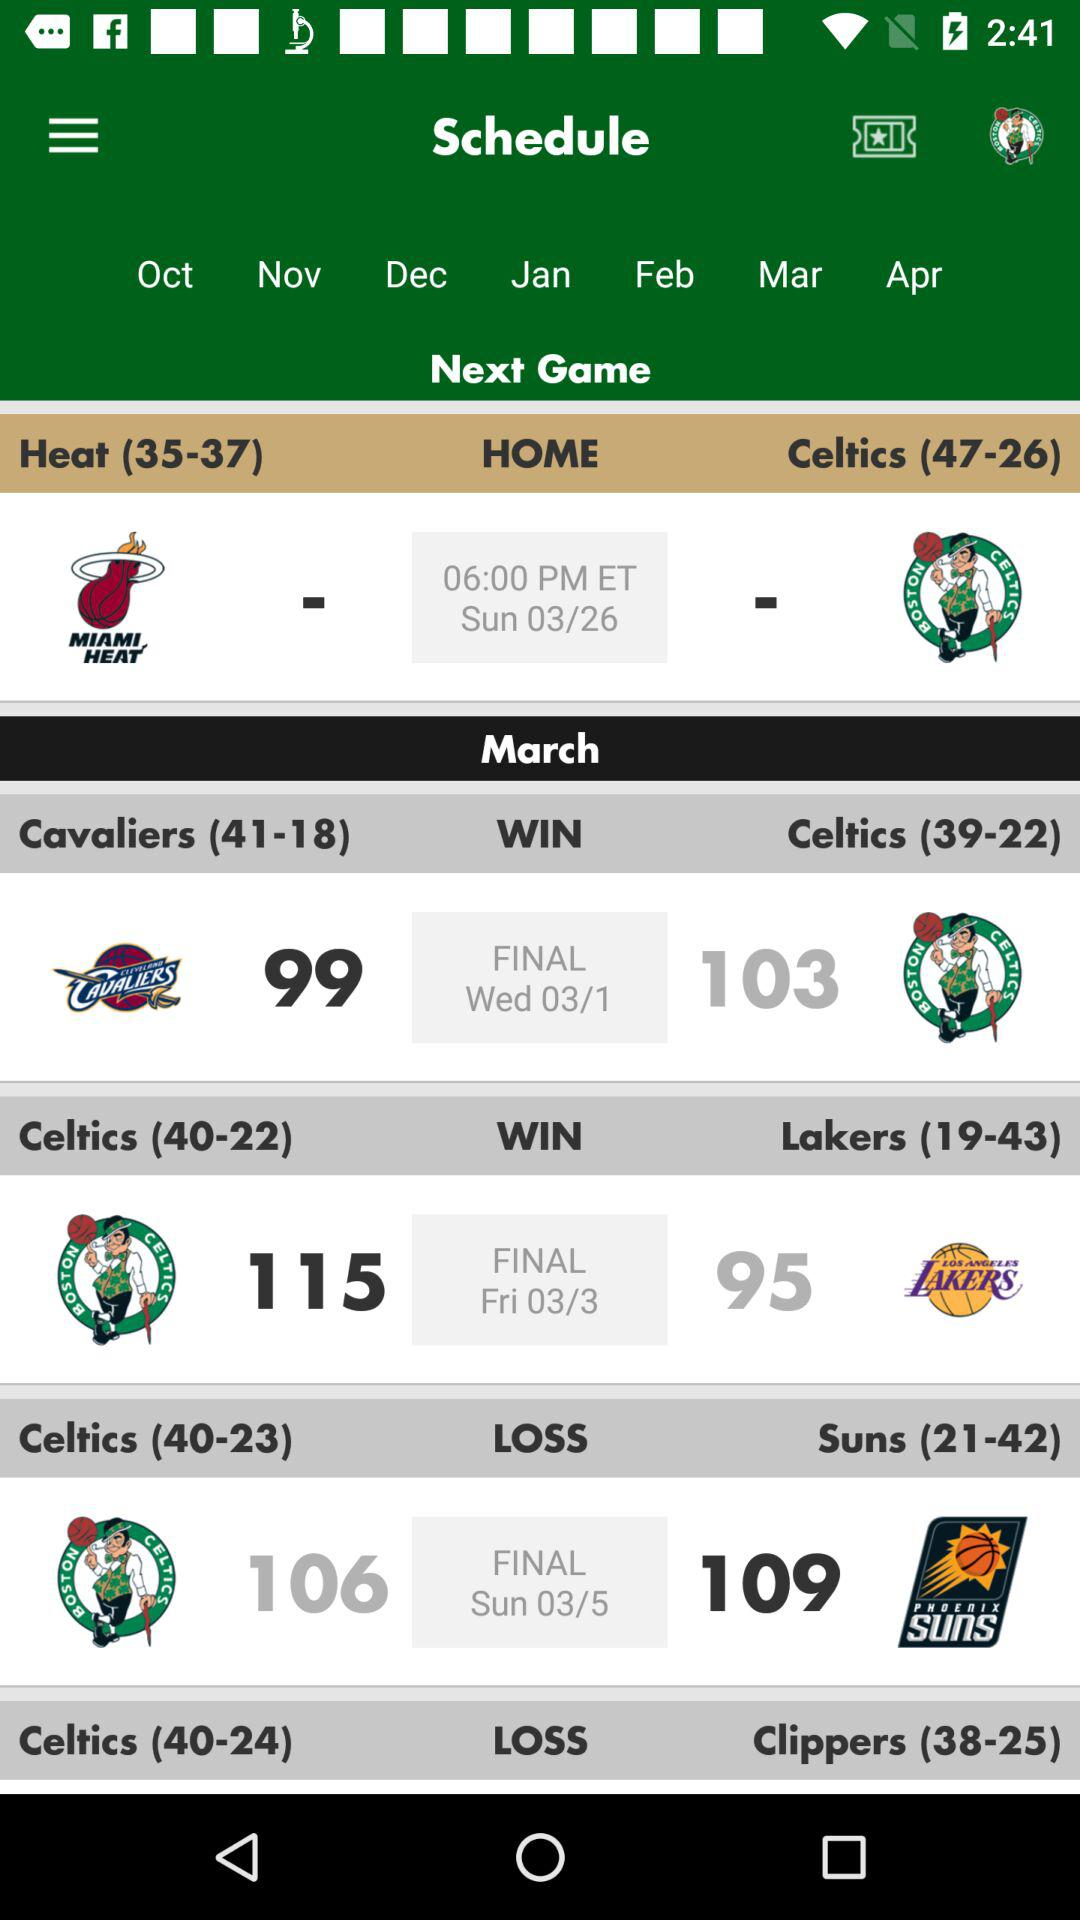When was the final match between the Celtics and Lakers? The final match between the Celtics and Lakers was on Friday, March 3. 